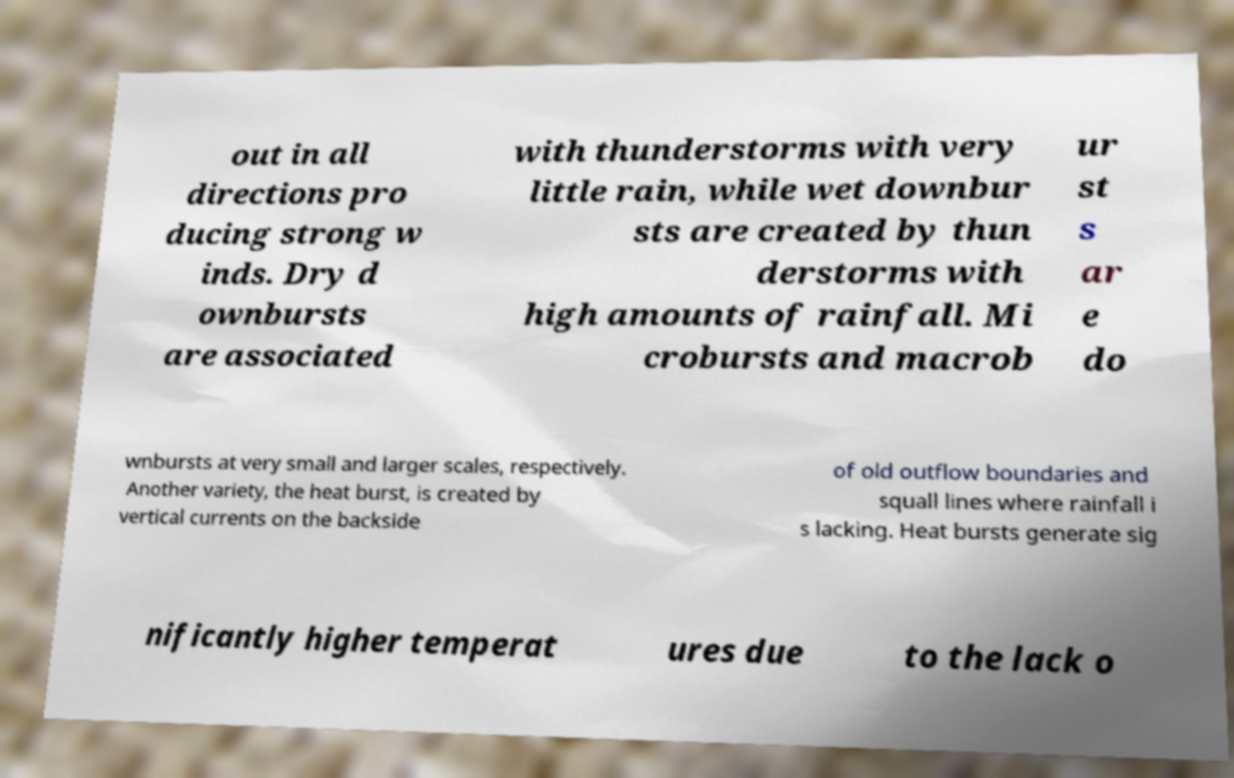Can you accurately transcribe the text from the provided image for me? out in all directions pro ducing strong w inds. Dry d ownbursts are associated with thunderstorms with very little rain, while wet downbur sts are created by thun derstorms with high amounts of rainfall. Mi crobursts and macrob ur st s ar e do wnbursts at very small and larger scales, respectively. Another variety, the heat burst, is created by vertical currents on the backside of old outflow boundaries and squall lines where rainfall i s lacking. Heat bursts generate sig nificantly higher temperat ures due to the lack o 